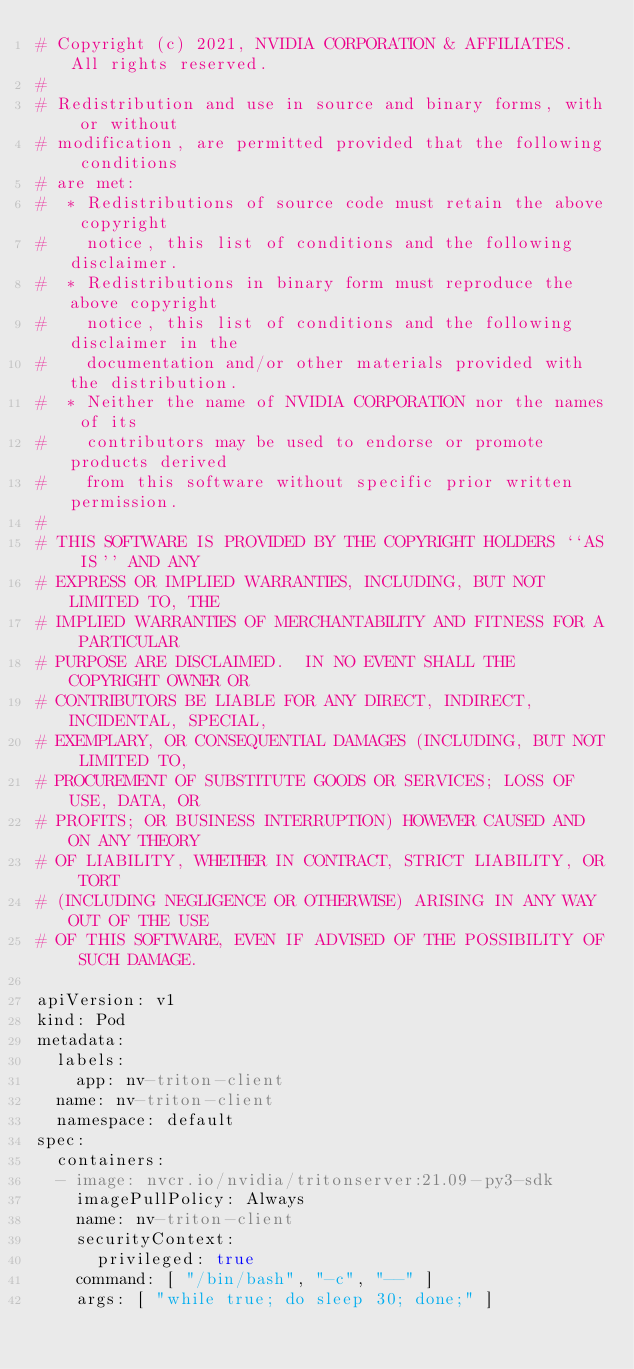Convert code to text. <code><loc_0><loc_0><loc_500><loc_500><_YAML_># Copyright (c) 2021, NVIDIA CORPORATION & AFFILIATES. All rights reserved.
#
# Redistribution and use in source and binary forms, with or without
# modification, are permitted provided that the following conditions
# are met:
#  * Redistributions of source code must retain the above copyright
#    notice, this list of conditions and the following disclaimer.
#  * Redistributions in binary form must reproduce the above copyright
#    notice, this list of conditions and the following disclaimer in the
#    documentation and/or other materials provided with the distribution.
#  * Neither the name of NVIDIA CORPORATION nor the names of its
#    contributors may be used to endorse or promote products derived
#    from this software without specific prior written permission.
#
# THIS SOFTWARE IS PROVIDED BY THE COPYRIGHT HOLDERS ``AS IS'' AND ANY
# EXPRESS OR IMPLIED WARRANTIES, INCLUDING, BUT NOT LIMITED TO, THE
# IMPLIED WARRANTIES OF MERCHANTABILITY AND FITNESS FOR A PARTICULAR
# PURPOSE ARE DISCLAIMED.  IN NO EVENT SHALL THE COPYRIGHT OWNER OR
# CONTRIBUTORS BE LIABLE FOR ANY DIRECT, INDIRECT, INCIDENTAL, SPECIAL,
# EXEMPLARY, OR CONSEQUENTIAL DAMAGES (INCLUDING, BUT NOT LIMITED TO,
# PROCUREMENT OF SUBSTITUTE GOODS OR SERVICES; LOSS OF USE, DATA, OR
# PROFITS; OR BUSINESS INTERRUPTION) HOWEVER CAUSED AND ON ANY THEORY
# OF LIABILITY, WHETHER IN CONTRACT, STRICT LIABILITY, OR TORT
# (INCLUDING NEGLIGENCE OR OTHERWISE) ARISING IN ANY WAY OUT OF THE USE
# OF THIS SOFTWARE, EVEN IF ADVISED OF THE POSSIBILITY OF SUCH DAMAGE.

apiVersion: v1
kind: Pod
metadata:
  labels:
    app: nv-triton-client
  name: nv-triton-client
  namespace: default
spec:
  containers:
  - image: nvcr.io/nvidia/tritonserver:21.09-py3-sdk
    imagePullPolicy: Always
    name: nv-triton-client
    securityContext:
      privileged: true
    command: [ "/bin/bash", "-c", "--" ]
    args: [ "while true; do sleep 30; done;" ]
</code> 